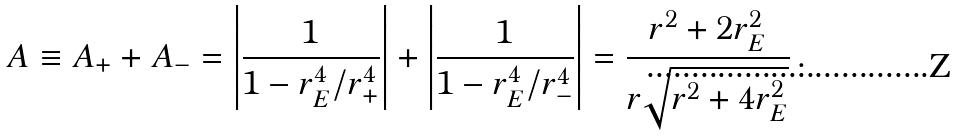Convert formula to latex. <formula><loc_0><loc_0><loc_500><loc_500>A \equiv A _ { + } + A _ { - } = \left | \frac { 1 } { 1 - r _ { E } ^ { 4 } / r _ { + } ^ { 4 } } \right | + \left | \frac { 1 } { 1 - r _ { E } ^ { 4 } / r _ { - } ^ { 4 } } \right | = \frac { r ^ { 2 } + 2 r _ { E } ^ { 2 } } { r \sqrt { r ^ { 2 } + 4 r _ { E } ^ { 2 } } } \, .</formula> 